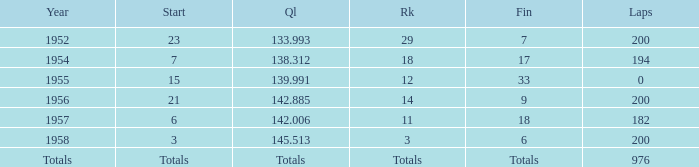What place did Jimmy Reece finish in 1957? 18.0. 